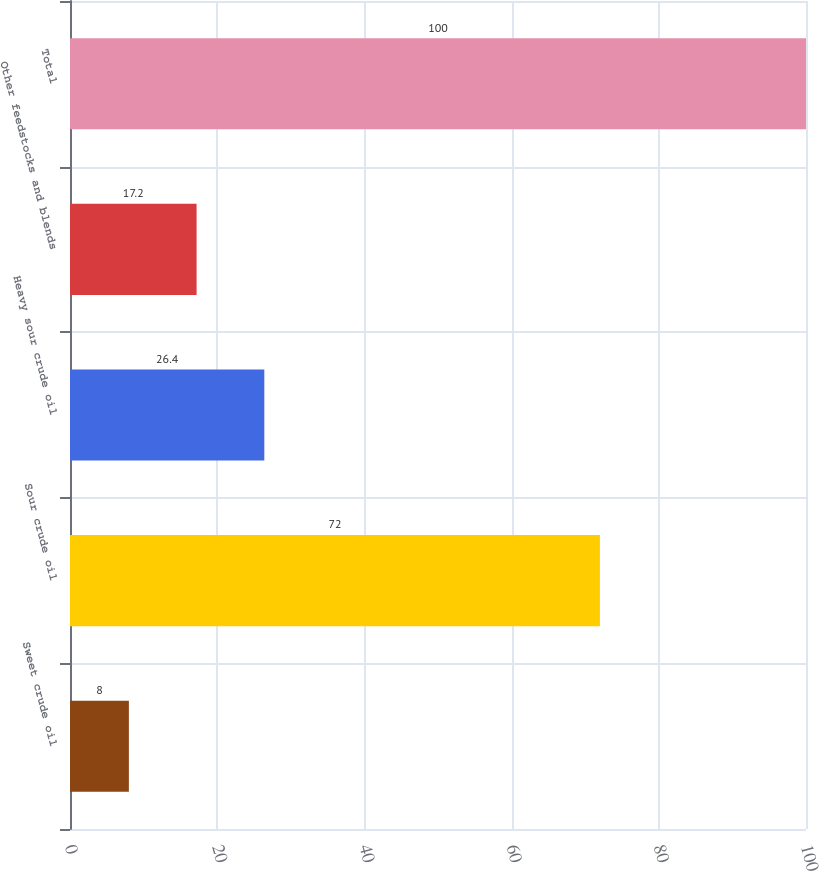<chart> <loc_0><loc_0><loc_500><loc_500><bar_chart><fcel>Sweet crude oil<fcel>Sour crude oil<fcel>Heavy sour crude oil<fcel>Other feedstocks and blends<fcel>Total<nl><fcel>8<fcel>72<fcel>26.4<fcel>17.2<fcel>100<nl></chart> 